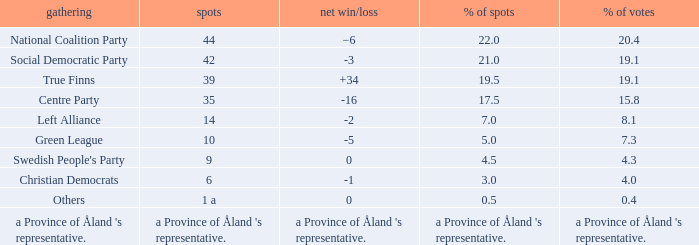Regarding the seats that casted 8.1% of the vote how many seats were held? 14.0. 